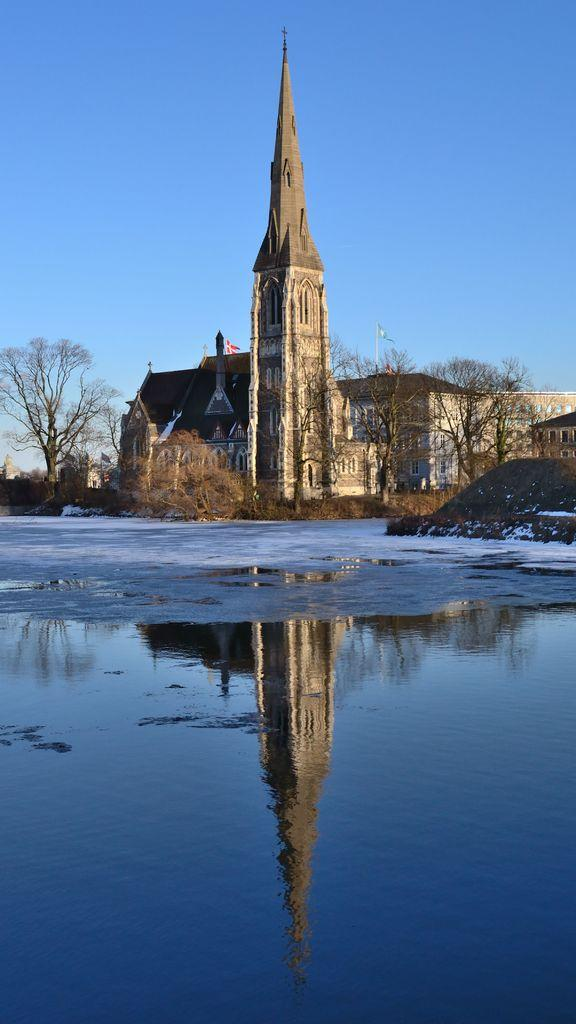What is the tall, pointed structure in the image? There is a spire in the image. What type of vegetation can be seen in the image? There are trees in the image. What natural element is visible in the image? Water is visible in the image. What color is the sky in the image? The sky is pale blue in the image. What is the reflection of in the water? The spire's reflection is visible in the water. What type of toothpaste is used to clean the spire in the image? There is no toothpaste present in the image, and the spire is not being cleaned. What disease is affecting the trees in the image? There is no indication of any disease affecting the trees in the image. 